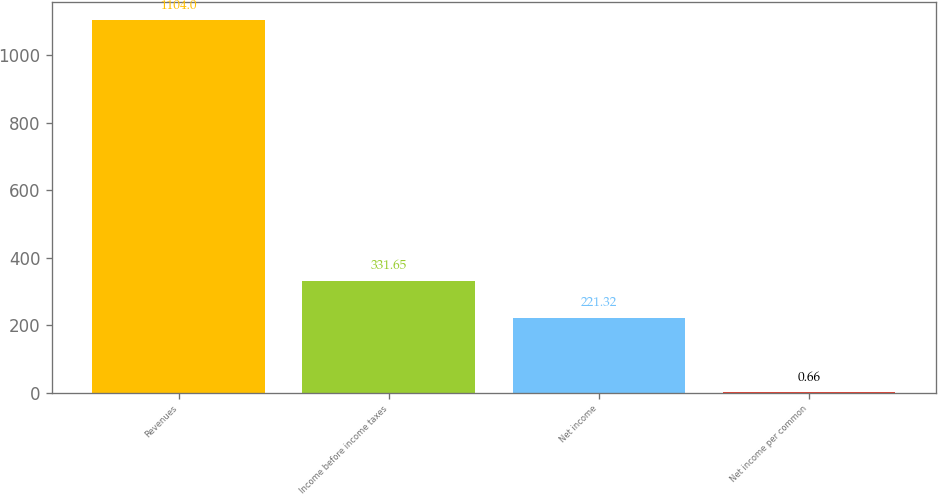Convert chart to OTSL. <chart><loc_0><loc_0><loc_500><loc_500><bar_chart><fcel>Revenues<fcel>Income before income taxes<fcel>Net income<fcel>Net income per common<nl><fcel>1104<fcel>331.65<fcel>221.32<fcel>0.66<nl></chart> 